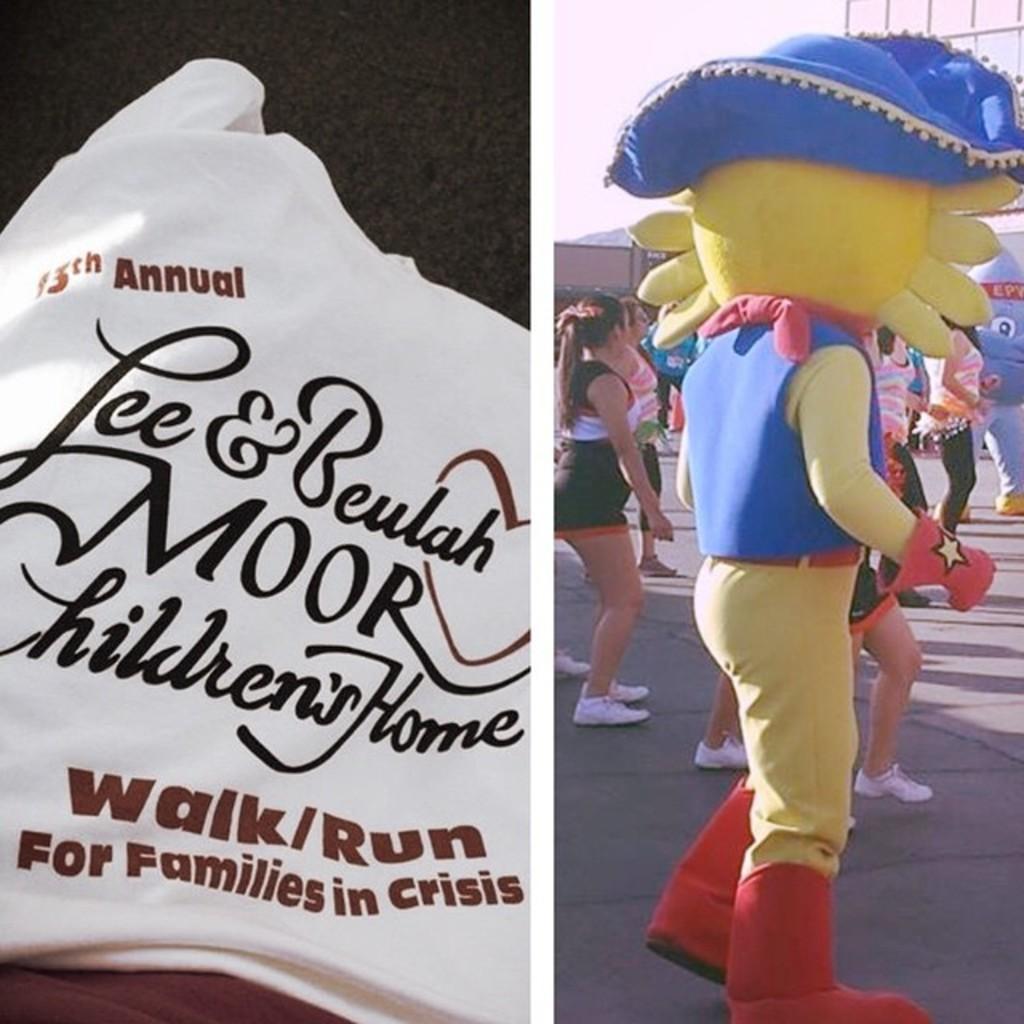Could you give a brief overview of what you see in this image? This is a collage. On the left side image there is something written on a white cloth. On the right side there are people and a person in a costume. 